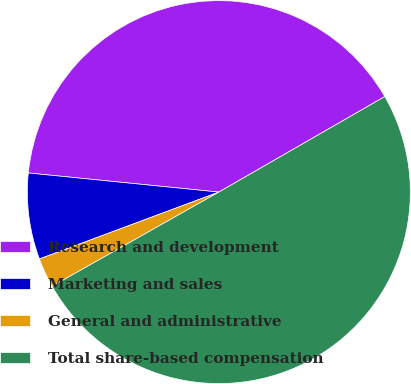Convert chart. <chart><loc_0><loc_0><loc_500><loc_500><pie_chart><fcel>Research and development<fcel>Marketing and sales<fcel>General and administrative<fcel>Total share-based compensation<nl><fcel>40.1%<fcel>7.27%<fcel>2.51%<fcel>50.13%<nl></chart> 